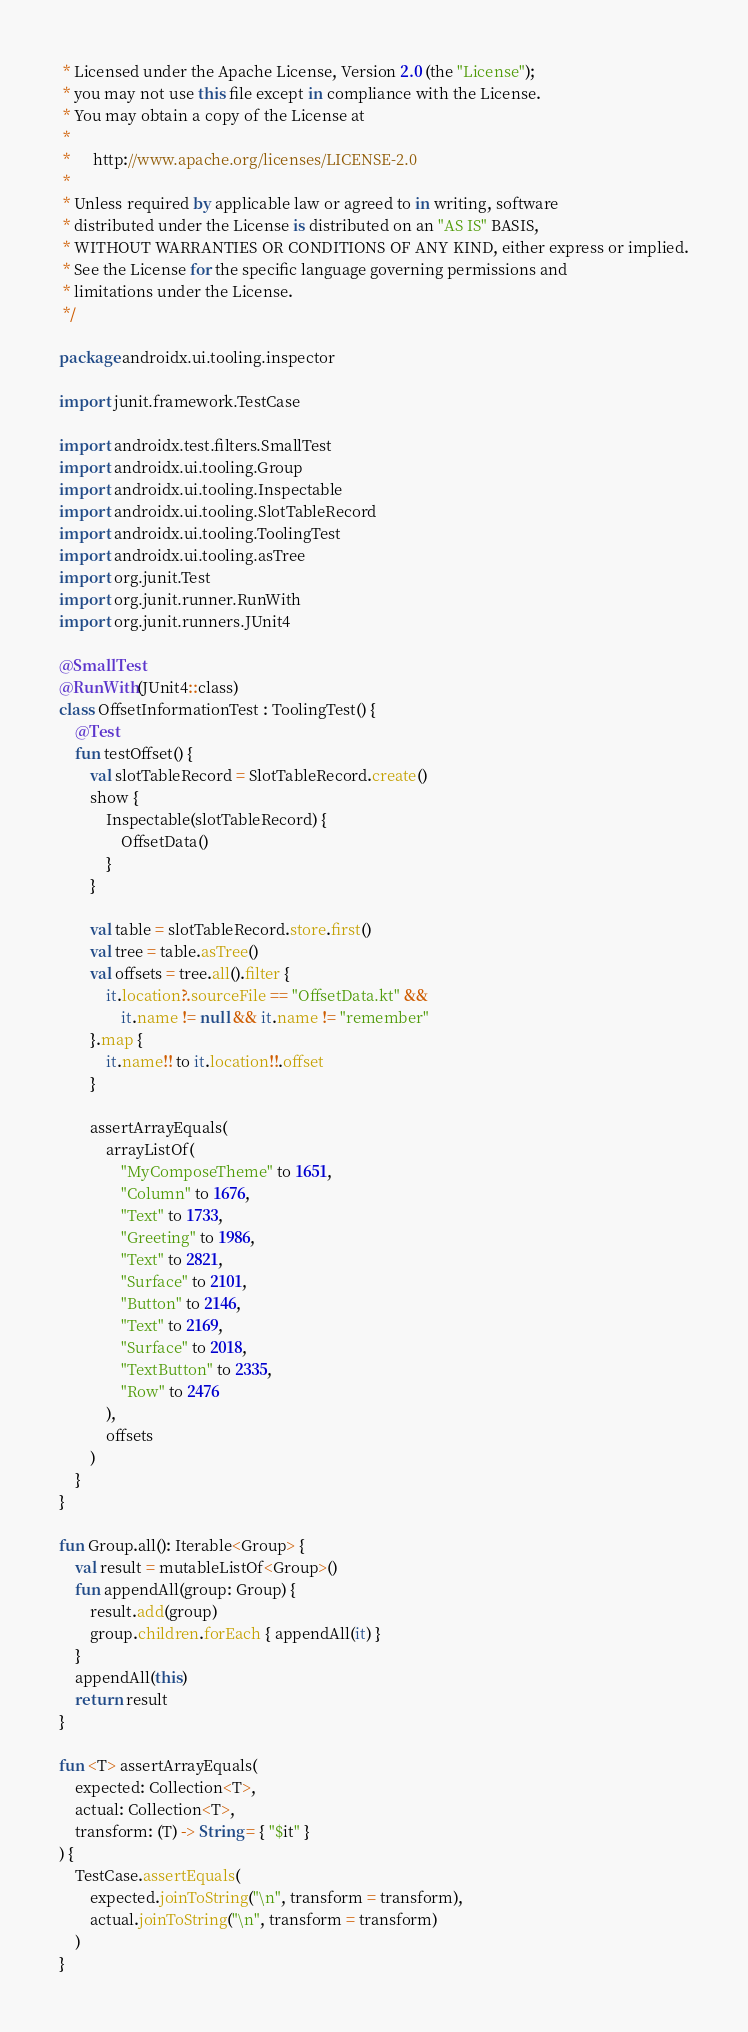Convert code to text. <code><loc_0><loc_0><loc_500><loc_500><_Kotlin_> * Licensed under the Apache License, Version 2.0 (the "License");
 * you may not use this file except in compliance with the License.
 * You may obtain a copy of the License at
 *
 *      http://www.apache.org/licenses/LICENSE-2.0
 *
 * Unless required by applicable law or agreed to in writing, software
 * distributed under the License is distributed on an "AS IS" BASIS,
 * WITHOUT WARRANTIES OR CONDITIONS OF ANY KIND, either express or implied.
 * See the License for the specific language governing permissions and
 * limitations under the License.
 */

package androidx.ui.tooling.inspector

import junit.framework.TestCase

import androidx.test.filters.SmallTest
import androidx.ui.tooling.Group
import androidx.ui.tooling.Inspectable
import androidx.ui.tooling.SlotTableRecord
import androidx.ui.tooling.ToolingTest
import androidx.ui.tooling.asTree
import org.junit.Test
import org.junit.runner.RunWith
import org.junit.runners.JUnit4

@SmallTest
@RunWith(JUnit4::class)
class OffsetInformationTest : ToolingTest() {
    @Test
    fun testOffset() {
        val slotTableRecord = SlotTableRecord.create()
        show {
            Inspectable(slotTableRecord) {
                OffsetData()
            }
        }

        val table = slotTableRecord.store.first()
        val tree = table.asTree()
        val offsets = tree.all().filter {
            it.location?.sourceFile == "OffsetData.kt" &&
                it.name != null && it.name != "remember"
        }.map {
            it.name!! to it.location!!.offset
        }

        assertArrayEquals(
            arrayListOf(
                "MyComposeTheme" to 1651,
                "Column" to 1676,
                "Text" to 1733,
                "Greeting" to 1986,
                "Text" to 2821,
                "Surface" to 2101,
                "Button" to 2146,
                "Text" to 2169,
                "Surface" to 2018,
                "TextButton" to 2335,
                "Row" to 2476
            ),
            offsets
        )
    }
}

fun Group.all(): Iterable<Group> {
    val result = mutableListOf<Group>()
    fun appendAll(group: Group) {
        result.add(group)
        group.children.forEach { appendAll(it) }
    }
    appendAll(this)
    return result
}

fun <T> assertArrayEquals(
    expected: Collection<T>,
    actual: Collection<T>,
    transform: (T) -> String = { "$it" }
) {
    TestCase.assertEquals(
        expected.joinToString("\n", transform = transform),
        actual.joinToString("\n", transform = transform)
    )
}
</code> 